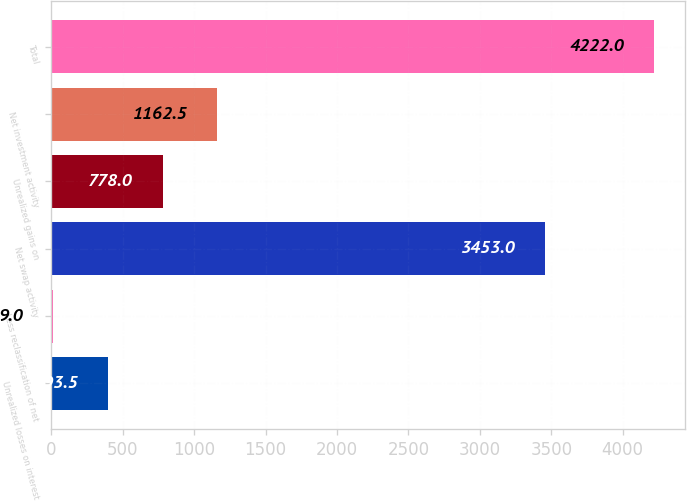Convert chart to OTSL. <chart><loc_0><loc_0><loc_500><loc_500><bar_chart><fcel>Unrealized losses on interest<fcel>Less reclassification of net<fcel>Net swap activity<fcel>Unrealized gains on<fcel>Net investment activity<fcel>Total<nl><fcel>393.5<fcel>9<fcel>3453<fcel>778<fcel>1162.5<fcel>4222<nl></chart> 